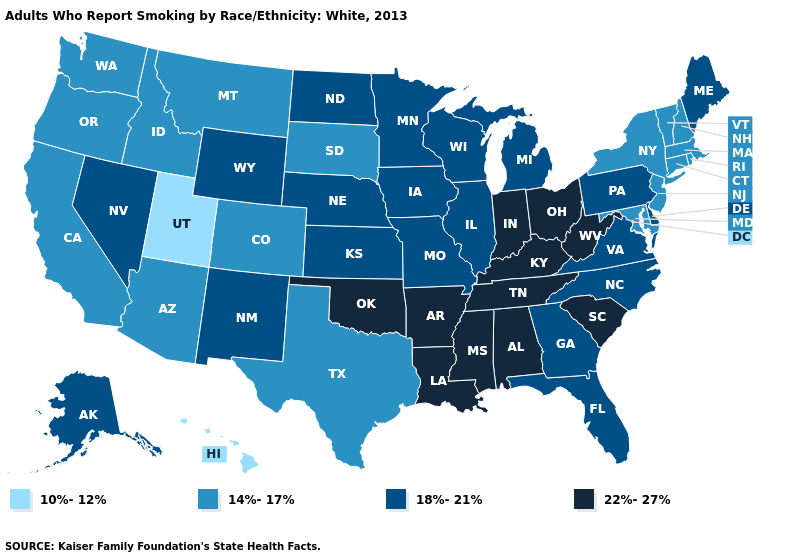What is the value of North Dakota?
Short answer required. 18%-21%. Name the states that have a value in the range 18%-21%?
Give a very brief answer. Alaska, Delaware, Florida, Georgia, Illinois, Iowa, Kansas, Maine, Michigan, Minnesota, Missouri, Nebraska, Nevada, New Mexico, North Carolina, North Dakota, Pennsylvania, Virginia, Wisconsin, Wyoming. Name the states that have a value in the range 14%-17%?
Short answer required. Arizona, California, Colorado, Connecticut, Idaho, Maryland, Massachusetts, Montana, New Hampshire, New Jersey, New York, Oregon, Rhode Island, South Dakota, Texas, Vermont, Washington. What is the value of North Dakota?
Short answer required. 18%-21%. What is the value of Ohio?
Write a very short answer. 22%-27%. Does Oklahoma have a higher value than Missouri?
Be succinct. Yes. Name the states that have a value in the range 14%-17%?
Keep it brief. Arizona, California, Colorado, Connecticut, Idaho, Maryland, Massachusetts, Montana, New Hampshire, New Jersey, New York, Oregon, Rhode Island, South Dakota, Texas, Vermont, Washington. Does Nebraska have the highest value in the MidWest?
Be succinct. No. Does Vermont have a lower value than Oklahoma?
Short answer required. Yes. What is the highest value in states that border Delaware?
Quick response, please. 18%-21%. Does the first symbol in the legend represent the smallest category?
Write a very short answer. Yes. Which states have the highest value in the USA?
Write a very short answer. Alabama, Arkansas, Indiana, Kentucky, Louisiana, Mississippi, Ohio, Oklahoma, South Carolina, Tennessee, West Virginia. What is the value of Pennsylvania?
Keep it brief. 18%-21%. What is the value of Louisiana?
Quick response, please. 22%-27%. What is the lowest value in states that border Virginia?
Answer briefly. 14%-17%. 